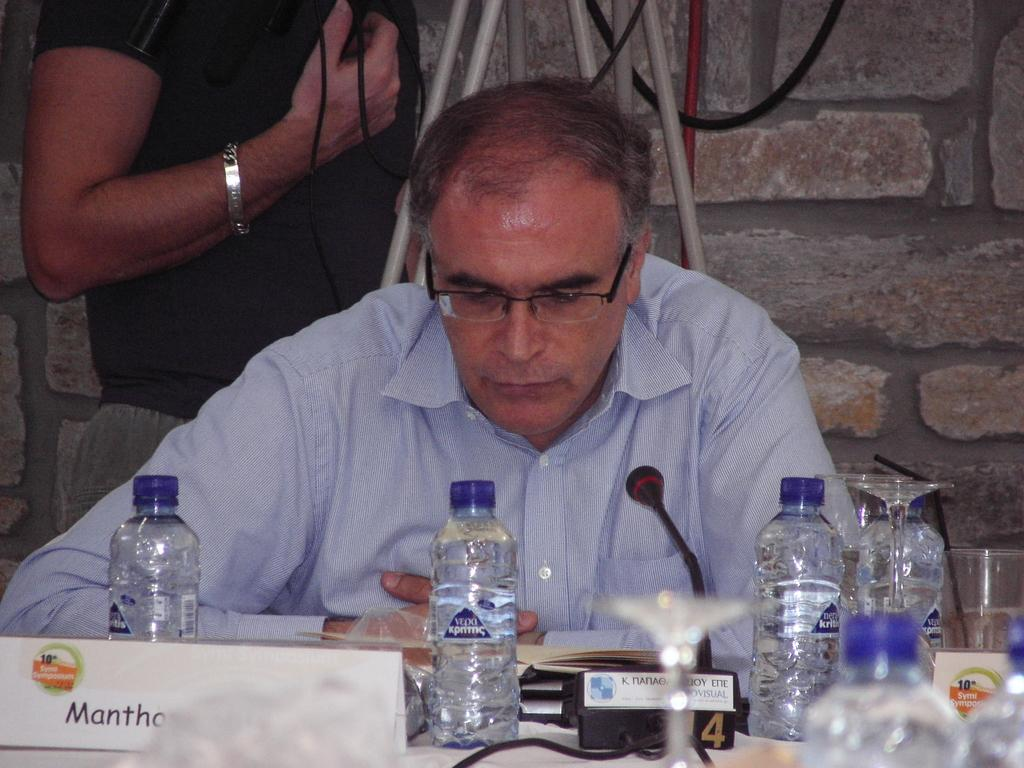Who is present in the image? There is a man in the image. What is the man wearing? The man is wearing spectacles. What can be seen on the table in the image? There are bottles and a microphone (mike) on the table. What is visible in the background of the image? There is a wall and cables visible in the background. What type of bird is perched on the manager's shoulder in the image? There is no manager or bird present in the image. What kind of ray is visible in the image? There is no ray visible in the image. 